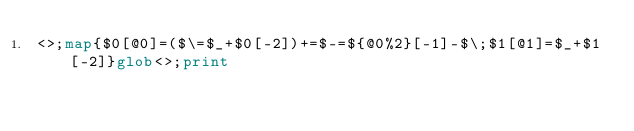<code> <loc_0><loc_0><loc_500><loc_500><_Perl_><>;map{$0[@0]=($\=$_+$0[-2])+=$-=${@0%2}[-1]-$\;$1[@1]=$_+$1[-2]}glob<>;print</code> 